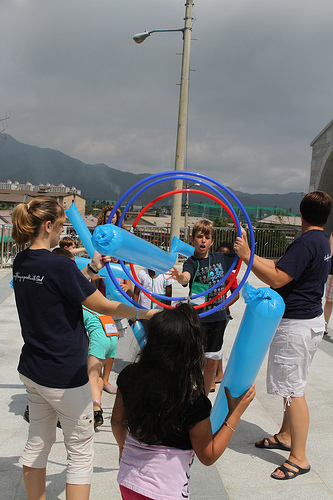<image>
Is there a little boy on the little girl? No. The little boy is not positioned on the little girl. They may be near each other, but the little boy is not supported by or resting on top of the little girl. 